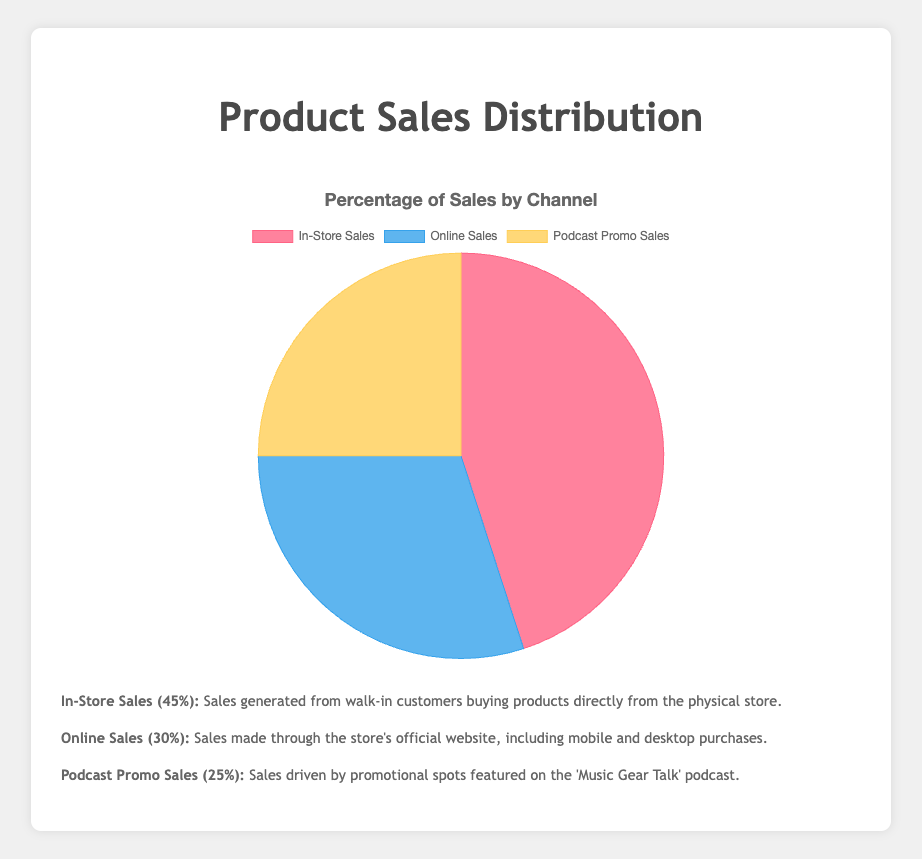What percentage of total sales come from the physical store? Referring to the pie chart, the portion labeled "In-Store Sales" represents sales generated from walk-in customers, with a percentage value of 45%.
Answer: 45% What is the combined percentage of online sales and podcast promo sales? The chart indicates that online sales and podcast promo sales are 30% and 25%, respectively. Adding these percentages together gives 30% + 25% = 55%.
Answer: 55% Which sales channel contributes the least to the total sales? By examining the pie chart, the "Podcast Promo Sales" segment has the smallest percentage, which is 25%.
Answer: Podcast Promo Sales How much larger is the percentage of in-store sales compared to online sales? The pie chart shows in-store sales at 45% and online sales at 30%. The difference between them is 45% - 30% = 15%.
Answer: 15% What percentage of sales are not accounted for by in-store sales? From the pie chart, in-store sales are 45%, so the remaining percentage would be 100% - 45% = 55%, which includes online and podcast promo sales.
Answer: 55% What is the average percentage of the three sales channels? The segments in the pie chart represent percentages of 45%, 30%, and 25%. The average is calculated as (45% + 30% + 25%) / 3 = 33.33%.
Answer: 33.33% Is the percentage of podcast promo sales more than half of the in-store sales percentage? The pie chart shows that podcast promo sales are 25% and in-store sales are 45%. Half of in-store sales is 45% / 2 = 22.5%. Since 25% > 22.5%, the podcast promo sales percentage is more than half of the in-store sales.
Answer: Yes Which section of the pie chart is represented by the color red? Visually inspecting the pie chart, the section colored red corresponds to the "In-Store Sales" segment, which is 45%.
Answer: In-Store Sales If the store aims to increase online sales to match in-store sales, by what percentage do online sales need to increase? Currently, online sales are at 30% and in-store sales are at 45%. To match in-store sales, online sales need to increase by 45% - 30% = 15%.
Answer: 15% 